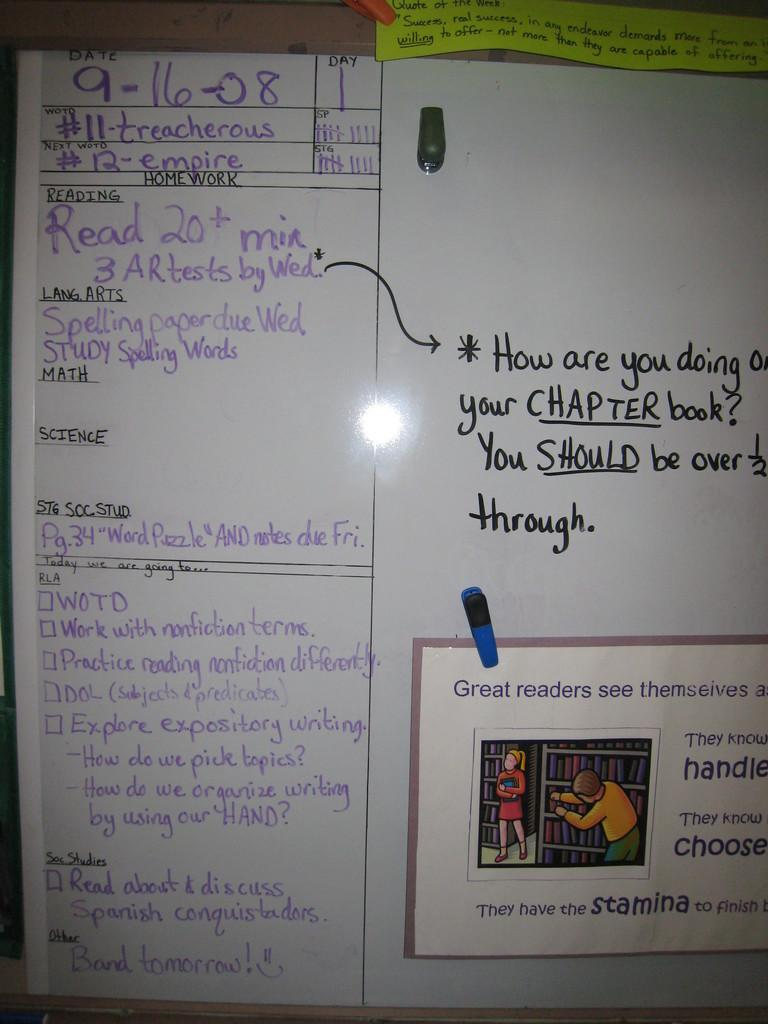<image>
Relay a brief, clear account of the picture shown. A homework worksheet is separated into sections for reading, math, science and more. 